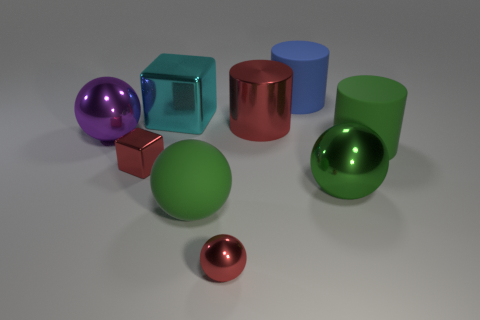Add 1 big cylinders. How many objects exist? 10 Subtract all spheres. How many objects are left? 5 Subtract all large metallic things. Subtract all tiny red metallic things. How many objects are left? 3 Add 6 big blue matte cylinders. How many big blue matte cylinders are left? 7 Add 6 green matte cylinders. How many green matte cylinders exist? 7 Subtract 0 cyan cylinders. How many objects are left? 9 